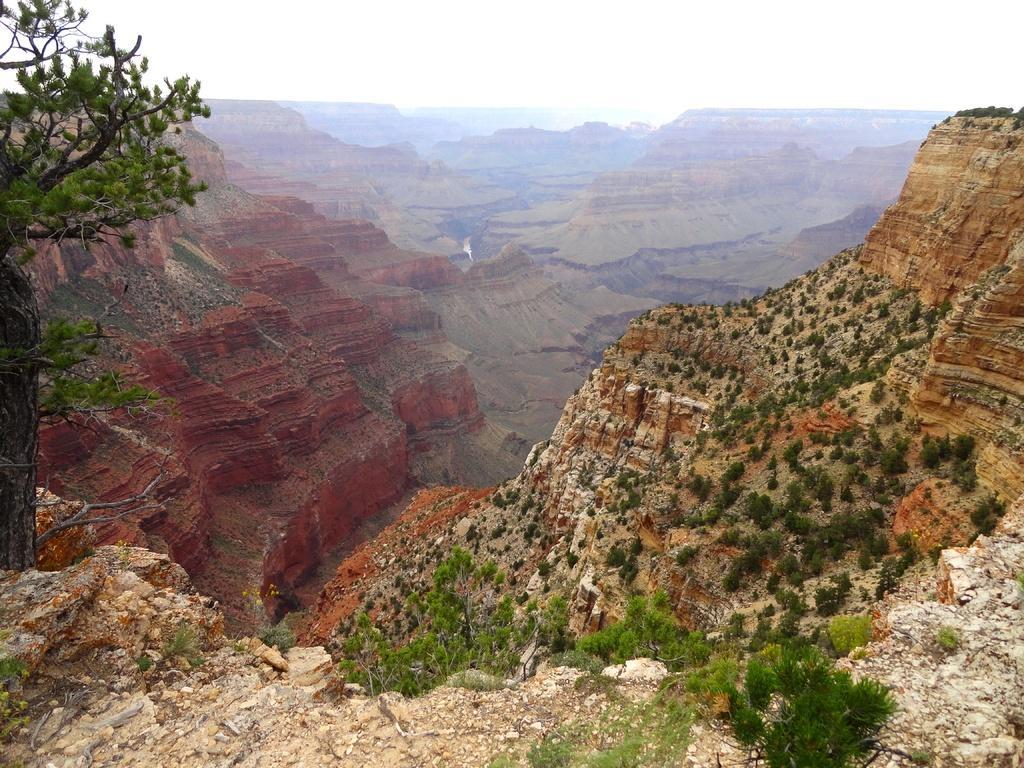In one or two sentences, can you explain what this image depicts? This picture is clicked outside. In the foreground we can see the plants. In the center we can see the cliffs. On the left we can see the tree. In the background we can see the sky and we can see some other items. 